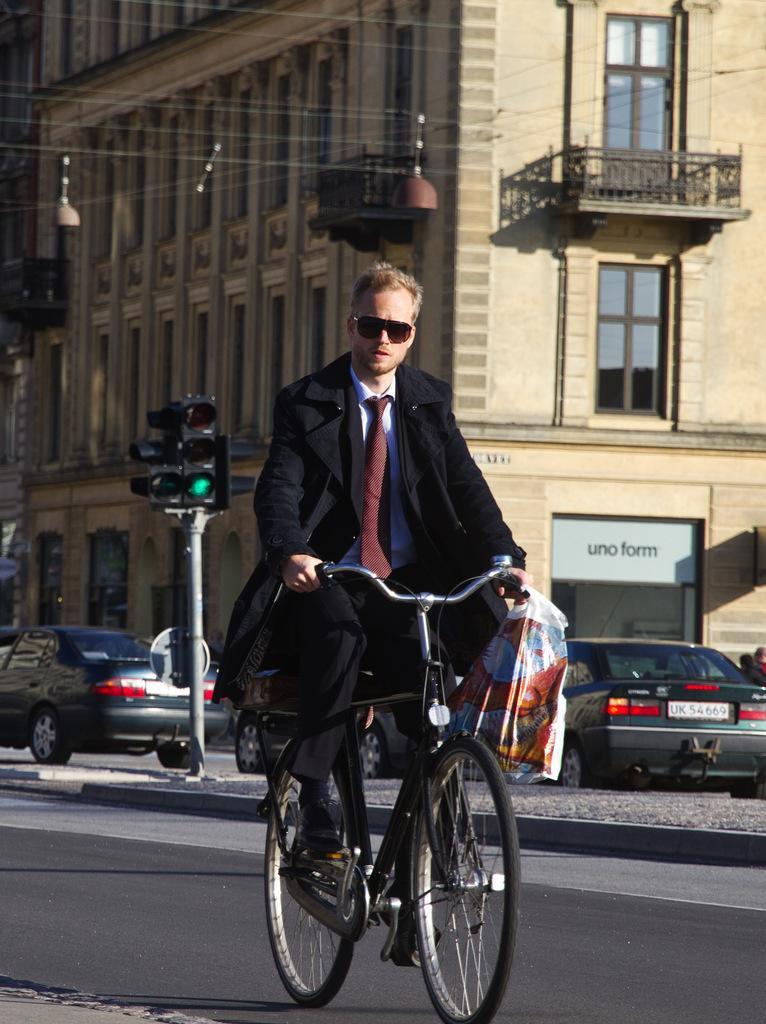Describe this image in one or two sentences. A man is riding bicycle and holding a bag in his hand. Behind him there are vehicles,traffic signal pole and a building. 